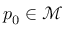Convert formula to latex. <formula><loc_0><loc_0><loc_500><loc_500>p _ { 0 } \in \mathcal { M }</formula> 